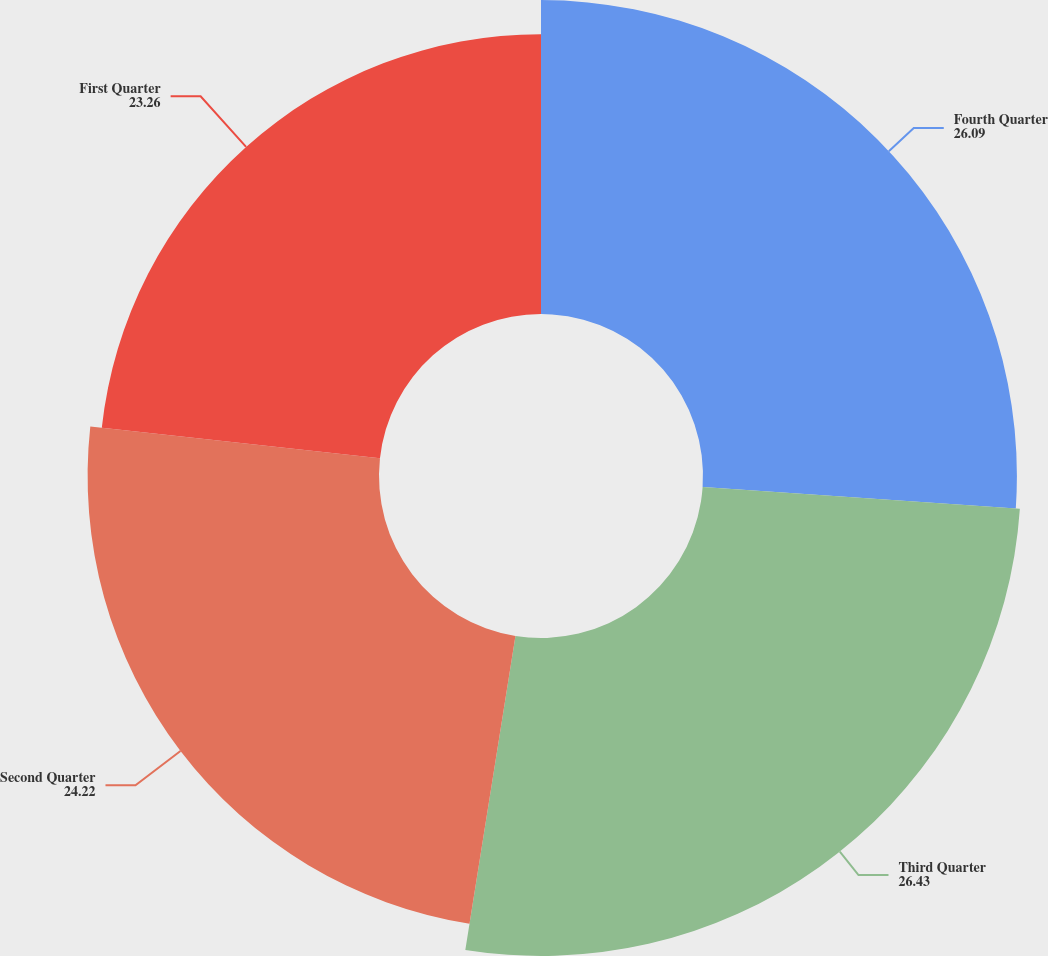Convert chart. <chart><loc_0><loc_0><loc_500><loc_500><pie_chart><fcel>Fourth Quarter<fcel>Third Quarter<fcel>Second Quarter<fcel>First Quarter<nl><fcel>26.09%<fcel>26.43%<fcel>24.22%<fcel>23.26%<nl></chart> 